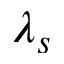Convert formula to latex. <formula><loc_0><loc_0><loc_500><loc_500>\lambda _ { s }</formula> 